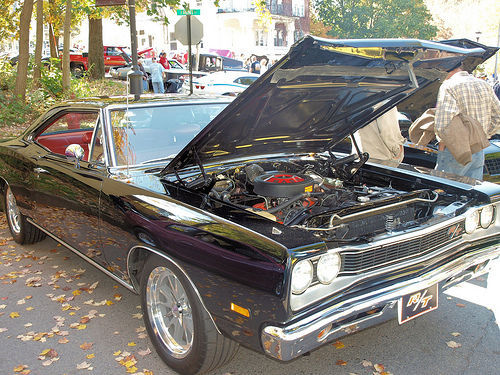<image>
Is the car above the road? No. The car is not positioned above the road. The vertical arrangement shows a different relationship. 